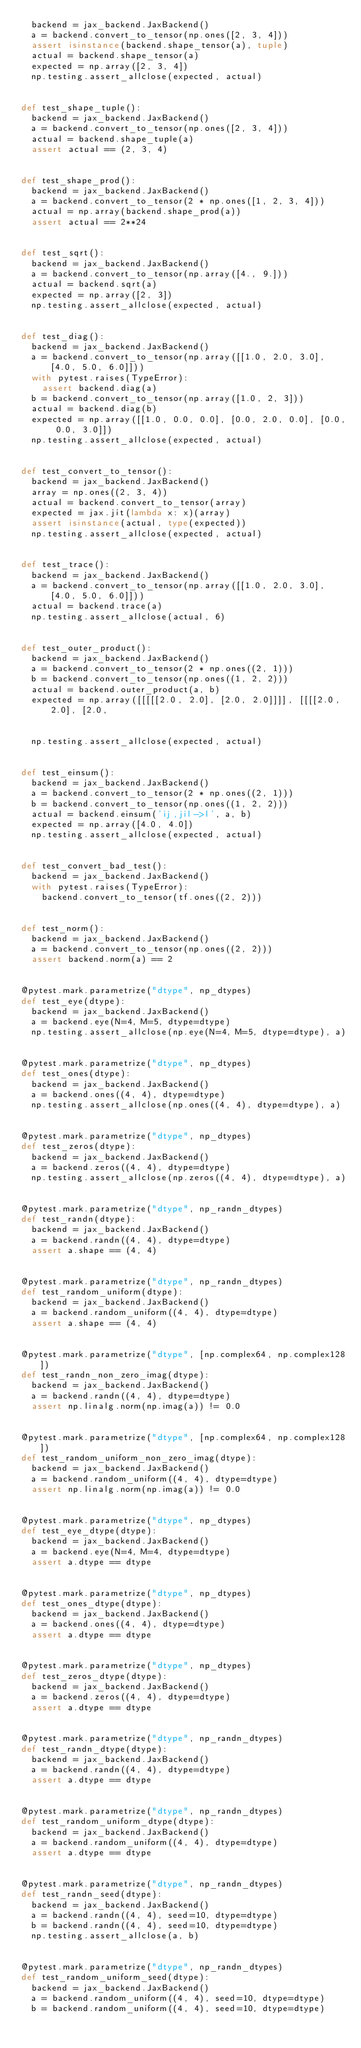<code> <loc_0><loc_0><loc_500><loc_500><_Python_>  backend = jax_backend.JaxBackend()
  a = backend.convert_to_tensor(np.ones([2, 3, 4]))
  assert isinstance(backend.shape_tensor(a), tuple)
  actual = backend.shape_tensor(a)
  expected = np.array([2, 3, 4])
  np.testing.assert_allclose(expected, actual)


def test_shape_tuple():
  backend = jax_backend.JaxBackend()
  a = backend.convert_to_tensor(np.ones([2, 3, 4]))
  actual = backend.shape_tuple(a)
  assert actual == (2, 3, 4)


def test_shape_prod():
  backend = jax_backend.JaxBackend()
  a = backend.convert_to_tensor(2 * np.ones([1, 2, 3, 4]))
  actual = np.array(backend.shape_prod(a))
  assert actual == 2**24


def test_sqrt():
  backend = jax_backend.JaxBackend()
  a = backend.convert_to_tensor(np.array([4., 9.]))
  actual = backend.sqrt(a)
  expected = np.array([2, 3])
  np.testing.assert_allclose(expected, actual)


def test_diag():
  backend = jax_backend.JaxBackend()
  a = backend.convert_to_tensor(np.array([[1.0, 2.0, 3.0], [4.0, 5.0, 6.0]]))
  with pytest.raises(TypeError):
    assert backend.diag(a)
  b = backend.convert_to_tensor(np.array([1.0, 2, 3]))
  actual = backend.diag(b)
  expected = np.array([[1.0, 0.0, 0.0], [0.0, 2.0, 0.0], [0.0, 0.0, 3.0]])
  np.testing.assert_allclose(expected, actual)


def test_convert_to_tensor():
  backend = jax_backend.JaxBackend()
  array = np.ones((2, 3, 4))
  actual = backend.convert_to_tensor(array)
  expected = jax.jit(lambda x: x)(array)
  assert isinstance(actual, type(expected))
  np.testing.assert_allclose(expected, actual)


def test_trace():
  backend = jax_backend.JaxBackend()
  a = backend.convert_to_tensor(np.array([[1.0, 2.0, 3.0], [4.0, 5.0, 6.0]]))
  actual = backend.trace(a)
  np.testing.assert_allclose(actual, 6)


def test_outer_product():
  backend = jax_backend.JaxBackend()
  a = backend.convert_to_tensor(2 * np.ones((2, 1)))
  b = backend.convert_to_tensor(np.ones((1, 2, 2)))
  actual = backend.outer_product(a, b)
  expected = np.array([[[[[2.0, 2.0], [2.0, 2.0]]]], [[[[2.0, 2.0], [2.0,
                                                                     2.0]]]]])
  np.testing.assert_allclose(expected, actual)


def test_einsum():
  backend = jax_backend.JaxBackend()
  a = backend.convert_to_tensor(2 * np.ones((2, 1)))
  b = backend.convert_to_tensor(np.ones((1, 2, 2)))
  actual = backend.einsum('ij,jil->l', a, b)
  expected = np.array([4.0, 4.0])
  np.testing.assert_allclose(expected, actual)


def test_convert_bad_test():
  backend = jax_backend.JaxBackend()
  with pytest.raises(TypeError):
    backend.convert_to_tensor(tf.ones((2, 2)))


def test_norm():
  backend = jax_backend.JaxBackend()
  a = backend.convert_to_tensor(np.ones((2, 2)))
  assert backend.norm(a) == 2


@pytest.mark.parametrize("dtype", np_dtypes)
def test_eye(dtype):
  backend = jax_backend.JaxBackend()
  a = backend.eye(N=4, M=5, dtype=dtype)
  np.testing.assert_allclose(np.eye(N=4, M=5, dtype=dtype), a)


@pytest.mark.parametrize("dtype", np_dtypes)
def test_ones(dtype):
  backend = jax_backend.JaxBackend()
  a = backend.ones((4, 4), dtype=dtype)
  np.testing.assert_allclose(np.ones((4, 4), dtype=dtype), a)


@pytest.mark.parametrize("dtype", np_dtypes)
def test_zeros(dtype):
  backend = jax_backend.JaxBackend()
  a = backend.zeros((4, 4), dtype=dtype)
  np.testing.assert_allclose(np.zeros((4, 4), dtype=dtype), a)


@pytest.mark.parametrize("dtype", np_randn_dtypes)
def test_randn(dtype):
  backend = jax_backend.JaxBackend()
  a = backend.randn((4, 4), dtype=dtype)
  assert a.shape == (4, 4)


@pytest.mark.parametrize("dtype", np_randn_dtypes)
def test_random_uniform(dtype):
  backend = jax_backend.JaxBackend()
  a = backend.random_uniform((4, 4), dtype=dtype)
  assert a.shape == (4, 4)


@pytest.mark.parametrize("dtype", [np.complex64, np.complex128])
def test_randn_non_zero_imag(dtype):
  backend = jax_backend.JaxBackend()
  a = backend.randn((4, 4), dtype=dtype)
  assert np.linalg.norm(np.imag(a)) != 0.0


@pytest.mark.parametrize("dtype", [np.complex64, np.complex128])
def test_random_uniform_non_zero_imag(dtype):
  backend = jax_backend.JaxBackend()
  a = backend.random_uniform((4, 4), dtype=dtype)
  assert np.linalg.norm(np.imag(a)) != 0.0


@pytest.mark.parametrize("dtype", np_dtypes)
def test_eye_dtype(dtype):
  backend = jax_backend.JaxBackend()
  a = backend.eye(N=4, M=4, dtype=dtype)
  assert a.dtype == dtype


@pytest.mark.parametrize("dtype", np_dtypes)
def test_ones_dtype(dtype):
  backend = jax_backend.JaxBackend()
  a = backend.ones((4, 4), dtype=dtype)
  assert a.dtype == dtype


@pytest.mark.parametrize("dtype", np_dtypes)
def test_zeros_dtype(dtype):
  backend = jax_backend.JaxBackend()
  a = backend.zeros((4, 4), dtype=dtype)
  assert a.dtype == dtype


@pytest.mark.parametrize("dtype", np_randn_dtypes)
def test_randn_dtype(dtype):
  backend = jax_backend.JaxBackend()
  a = backend.randn((4, 4), dtype=dtype)
  assert a.dtype == dtype


@pytest.mark.parametrize("dtype", np_randn_dtypes)
def test_random_uniform_dtype(dtype):
  backend = jax_backend.JaxBackend()
  a = backend.random_uniform((4, 4), dtype=dtype)
  assert a.dtype == dtype


@pytest.mark.parametrize("dtype", np_randn_dtypes)
def test_randn_seed(dtype):
  backend = jax_backend.JaxBackend()
  a = backend.randn((4, 4), seed=10, dtype=dtype)
  b = backend.randn((4, 4), seed=10, dtype=dtype)
  np.testing.assert_allclose(a, b)


@pytest.mark.parametrize("dtype", np_randn_dtypes)
def test_random_uniform_seed(dtype):
  backend = jax_backend.JaxBackend()
  a = backend.random_uniform((4, 4), seed=10, dtype=dtype)
  b = backend.random_uniform((4, 4), seed=10, dtype=dtype)</code> 